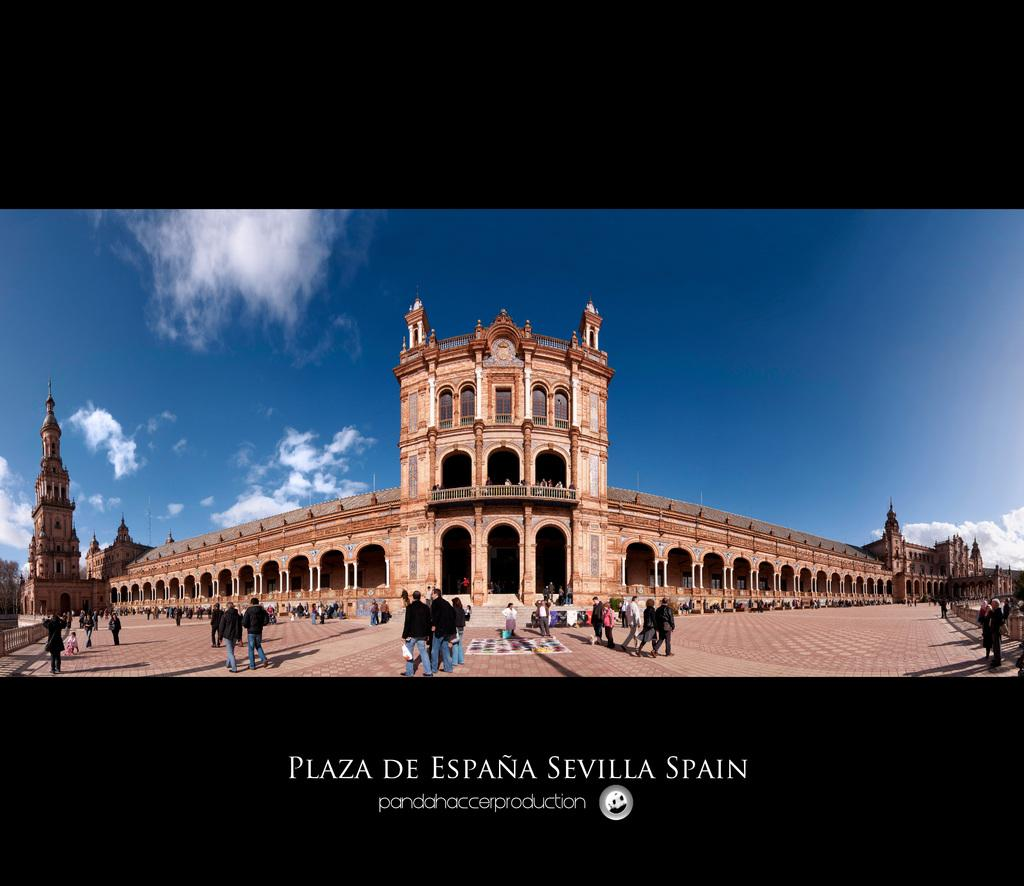What type of structure is visible in the image? There is a fort in the image. Can you describe the people in the image? There are people in the image. What is the path used for in the image? The path is visible in the image. What type of vegetation is present in the image? There are trees in the image. What is the purpose of the railing in the image? There is a railing in the image. What can be seen in the sky in the image? The sky is visible in the image, and there are clouds in the sky. What is written at the bottom of the image? There is text at the bottom of the image. What symbol is present at the bottom of the image? There is a logo at the bottom of the image. What is the title of the book being read by the judge in the image? There is no judge or book present in the image. What is the plot of the story being told by the trees in the image? Trees do not tell stories or have plots; they are a type of vegetation. 